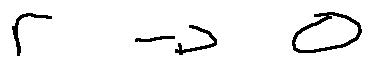Convert formula to latex. <formula><loc_0><loc_0><loc_500><loc_500>r \rightarrow 0</formula> 